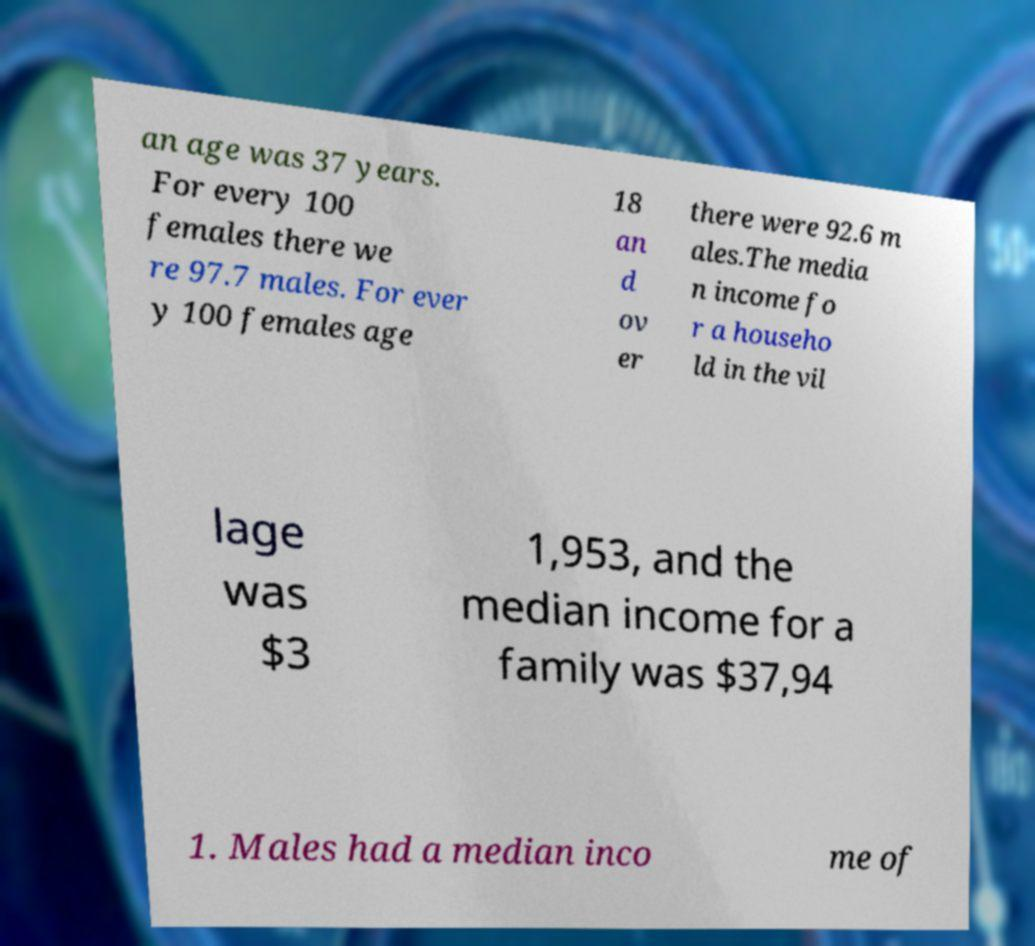I need the written content from this picture converted into text. Can you do that? an age was 37 years. For every 100 females there we re 97.7 males. For ever y 100 females age 18 an d ov er there were 92.6 m ales.The media n income fo r a househo ld in the vil lage was $3 1,953, and the median income for a family was $37,94 1. Males had a median inco me of 